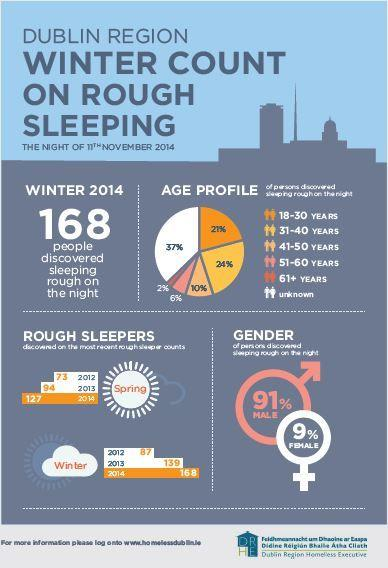Point out several critical features in this image. On the night of November 11th, 2014, a staggering 91% of males in the Dublin region were found to be sleeping rough. In the Dublin region on the night of November 11th, 2014, 24% of people in the age group of 31-40 years were sleeping rough. In the spring season of 2012, it was discovered that 73 rough sleepers existed. In the spring season of 2014, 127 rough sleepers were discovered. On the night of November 11th, 2014, in the Dublin region, 6% of individuals between the ages of 51 and 60 were found to be sleeping rough. 